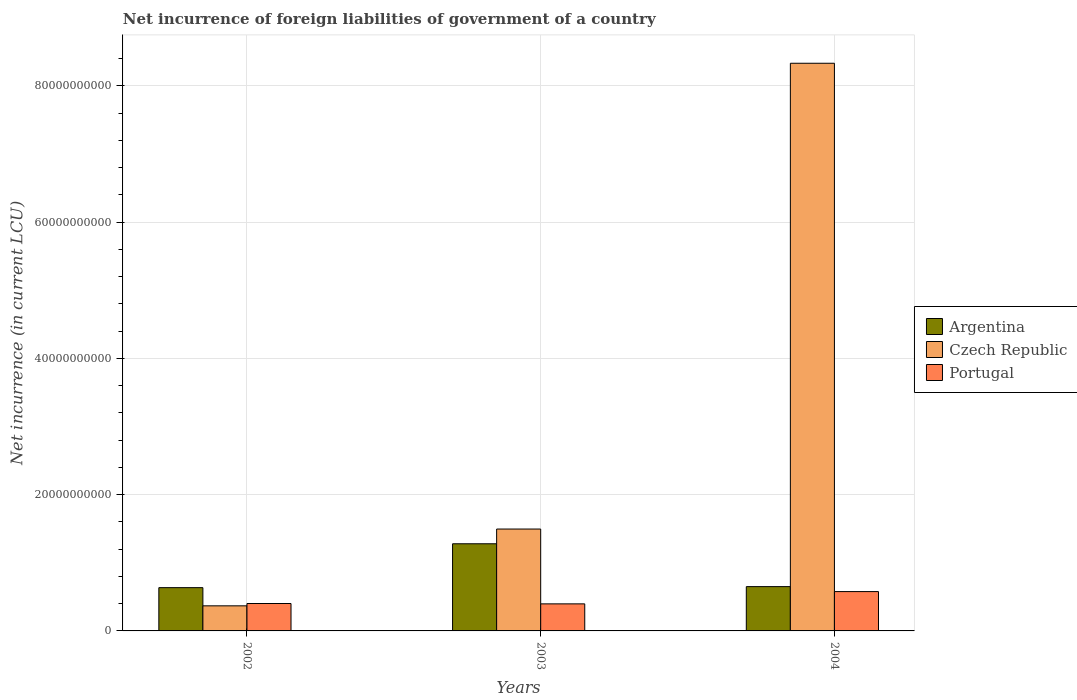Are the number of bars on each tick of the X-axis equal?
Provide a succinct answer. Yes. How many bars are there on the 1st tick from the left?
Provide a short and direct response. 3. How many bars are there on the 3rd tick from the right?
Offer a very short reply. 3. In how many cases, is the number of bars for a given year not equal to the number of legend labels?
Your answer should be very brief. 0. What is the net incurrence of foreign liabilities in Czech Republic in 2002?
Offer a very short reply. 3.68e+09. Across all years, what is the maximum net incurrence of foreign liabilities in Portugal?
Your answer should be compact. 5.77e+09. Across all years, what is the minimum net incurrence of foreign liabilities in Argentina?
Provide a succinct answer. 6.35e+09. What is the total net incurrence of foreign liabilities in Portugal in the graph?
Provide a short and direct response. 1.38e+1. What is the difference between the net incurrence of foreign liabilities in Portugal in 2003 and that in 2004?
Keep it short and to the point. -1.80e+09. What is the difference between the net incurrence of foreign liabilities in Portugal in 2003 and the net incurrence of foreign liabilities in Czech Republic in 2004?
Make the answer very short. -7.94e+1. What is the average net incurrence of foreign liabilities in Czech Republic per year?
Provide a short and direct response. 3.40e+1. In the year 2004, what is the difference between the net incurrence of foreign liabilities in Czech Republic and net incurrence of foreign liabilities in Portugal?
Your response must be concise. 7.76e+1. What is the ratio of the net incurrence of foreign liabilities in Argentina in 2003 to that in 2004?
Provide a succinct answer. 1.97. Is the net incurrence of foreign liabilities in Czech Republic in 2002 less than that in 2003?
Your answer should be very brief. Yes. Is the difference between the net incurrence of foreign liabilities in Czech Republic in 2003 and 2004 greater than the difference between the net incurrence of foreign liabilities in Portugal in 2003 and 2004?
Keep it short and to the point. No. What is the difference between the highest and the second highest net incurrence of foreign liabilities in Portugal?
Make the answer very short. 1.75e+09. What is the difference between the highest and the lowest net incurrence of foreign liabilities in Czech Republic?
Your response must be concise. 7.96e+1. Is the sum of the net incurrence of foreign liabilities in Portugal in 2002 and 2003 greater than the maximum net incurrence of foreign liabilities in Argentina across all years?
Give a very brief answer. No. Is it the case that in every year, the sum of the net incurrence of foreign liabilities in Argentina and net incurrence of foreign liabilities in Czech Republic is greater than the net incurrence of foreign liabilities in Portugal?
Offer a terse response. Yes. Are all the bars in the graph horizontal?
Provide a succinct answer. No. What is the difference between two consecutive major ticks on the Y-axis?
Make the answer very short. 2.00e+1. Does the graph contain any zero values?
Your response must be concise. No. Does the graph contain grids?
Offer a terse response. Yes. Where does the legend appear in the graph?
Ensure brevity in your answer.  Center right. What is the title of the graph?
Give a very brief answer. Net incurrence of foreign liabilities of government of a country. Does "Dominica" appear as one of the legend labels in the graph?
Make the answer very short. No. What is the label or title of the X-axis?
Provide a short and direct response. Years. What is the label or title of the Y-axis?
Give a very brief answer. Net incurrence (in current LCU). What is the Net incurrence (in current LCU) in Argentina in 2002?
Your answer should be very brief. 6.35e+09. What is the Net incurrence (in current LCU) of Czech Republic in 2002?
Make the answer very short. 3.68e+09. What is the Net incurrence (in current LCU) in Portugal in 2002?
Provide a short and direct response. 4.02e+09. What is the Net incurrence (in current LCU) of Argentina in 2003?
Ensure brevity in your answer.  1.28e+1. What is the Net incurrence (in current LCU) of Czech Republic in 2003?
Provide a succinct answer. 1.50e+1. What is the Net incurrence (in current LCU) in Portugal in 2003?
Your answer should be compact. 3.97e+09. What is the Net incurrence (in current LCU) in Argentina in 2004?
Offer a very short reply. 6.50e+09. What is the Net incurrence (in current LCU) of Czech Republic in 2004?
Ensure brevity in your answer.  8.33e+1. What is the Net incurrence (in current LCU) of Portugal in 2004?
Offer a terse response. 5.77e+09. Across all years, what is the maximum Net incurrence (in current LCU) of Argentina?
Your answer should be compact. 1.28e+1. Across all years, what is the maximum Net incurrence (in current LCU) of Czech Republic?
Make the answer very short. 8.33e+1. Across all years, what is the maximum Net incurrence (in current LCU) in Portugal?
Provide a succinct answer. 5.77e+09. Across all years, what is the minimum Net incurrence (in current LCU) of Argentina?
Make the answer very short. 6.35e+09. Across all years, what is the minimum Net incurrence (in current LCU) in Czech Republic?
Your answer should be compact. 3.68e+09. Across all years, what is the minimum Net incurrence (in current LCU) in Portugal?
Offer a terse response. 3.97e+09. What is the total Net incurrence (in current LCU) in Argentina in the graph?
Offer a very short reply. 2.56e+1. What is the total Net incurrence (in current LCU) of Czech Republic in the graph?
Your answer should be very brief. 1.02e+11. What is the total Net incurrence (in current LCU) in Portugal in the graph?
Make the answer very short. 1.38e+1. What is the difference between the Net incurrence (in current LCU) of Argentina in 2002 and that in 2003?
Your response must be concise. -6.44e+09. What is the difference between the Net incurrence (in current LCU) in Czech Republic in 2002 and that in 2003?
Offer a terse response. -1.13e+1. What is the difference between the Net incurrence (in current LCU) in Portugal in 2002 and that in 2003?
Provide a short and direct response. 5.12e+07. What is the difference between the Net incurrence (in current LCU) in Argentina in 2002 and that in 2004?
Keep it short and to the point. -1.53e+08. What is the difference between the Net incurrence (in current LCU) in Czech Republic in 2002 and that in 2004?
Make the answer very short. -7.96e+1. What is the difference between the Net incurrence (in current LCU) of Portugal in 2002 and that in 2004?
Ensure brevity in your answer.  -1.75e+09. What is the difference between the Net incurrence (in current LCU) of Argentina in 2003 and that in 2004?
Offer a terse response. 6.29e+09. What is the difference between the Net incurrence (in current LCU) of Czech Republic in 2003 and that in 2004?
Keep it short and to the point. -6.84e+1. What is the difference between the Net incurrence (in current LCU) in Portugal in 2003 and that in 2004?
Offer a very short reply. -1.80e+09. What is the difference between the Net incurrence (in current LCU) in Argentina in 2002 and the Net incurrence (in current LCU) in Czech Republic in 2003?
Keep it short and to the point. -8.60e+09. What is the difference between the Net incurrence (in current LCU) in Argentina in 2002 and the Net incurrence (in current LCU) in Portugal in 2003?
Your response must be concise. 2.38e+09. What is the difference between the Net incurrence (in current LCU) in Czech Republic in 2002 and the Net incurrence (in current LCU) in Portugal in 2003?
Your response must be concise. -2.90e+08. What is the difference between the Net incurrence (in current LCU) in Argentina in 2002 and the Net incurrence (in current LCU) in Czech Republic in 2004?
Offer a terse response. -7.70e+1. What is the difference between the Net incurrence (in current LCU) of Argentina in 2002 and the Net incurrence (in current LCU) of Portugal in 2004?
Offer a terse response. 5.77e+08. What is the difference between the Net incurrence (in current LCU) of Czech Republic in 2002 and the Net incurrence (in current LCU) of Portugal in 2004?
Your answer should be very brief. -2.09e+09. What is the difference between the Net incurrence (in current LCU) in Argentina in 2003 and the Net incurrence (in current LCU) in Czech Republic in 2004?
Ensure brevity in your answer.  -7.05e+1. What is the difference between the Net incurrence (in current LCU) in Argentina in 2003 and the Net incurrence (in current LCU) in Portugal in 2004?
Your answer should be very brief. 7.02e+09. What is the difference between the Net incurrence (in current LCU) in Czech Republic in 2003 and the Net incurrence (in current LCU) in Portugal in 2004?
Your answer should be compact. 9.18e+09. What is the average Net incurrence (in current LCU) of Argentina per year?
Your response must be concise. 8.55e+09. What is the average Net incurrence (in current LCU) of Czech Republic per year?
Your response must be concise. 3.40e+1. What is the average Net incurrence (in current LCU) in Portugal per year?
Offer a very short reply. 4.59e+09. In the year 2002, what is the difference between the Net incurrence (in current LCU) in Argentina and Net incurrence (in current LCU) in Czech Republic?
Your response must be concise. 2.67e+09. In the year 2002, what is the difference between the Net incurrence (in current LCU) in Argentina and Net incurrence (in current LCU) in Portugal?
Give a very brief answer. 2.33e+09. In the year 2002, what is the difference between the Net incurrence (in current LCU) in Czech Republic and Net incurrence (in current LCU) in Portugal?
Keep it short and to the point. -3.41e+08. In the year 2003, what is the difference between the Net incurrence (in current LCU) of Argentina and Net incurrence (in current LCU) of Czech Republic?
Your answer should be compact. -2.16e+09. In the year 2003, what is the difference between the Net incurrence (in current LCU) of Argentina and Net incurrence (in current LCU) of Portugal?
Provide a short and direct response. 8.82e+09. In the year 2003, what is the difference between the Net incurrence (in current LCU) of Czech Republic and Net incurrence (in current LCU) of Portugal?
Your response must be concise. 1.10e+1. In the year 2004, what is the difference between the Net incurrence (in current LCU) in Argentina and Net incurrence (in current LCU) in Czech Republic?
Give a very brief answer. -7.68e+1. In the year 2004, what is the difference between the Net incurrence (in current LCU) in Argentina and Net incurrence (in current LCU) in Portugal?
Offer a terse response. 7.30e+08. In the year 2004, what is the difference between the Net incurrence (in current LCU) in Czech Republic and Net incurrence (in current LCU) in Portugal?
Give a very brief answer. 7.76e+1. What is the ratio of the Net incurrence (in current LCU) of Argentina in 2002 to that in 2003?
Your response must be concise. 0.5. What is the ratio of the Net incurrence (in current LCU) of Czech Republic in 2002 to that in 2003?
Keep it short and to the point. 0.25. What is the ratio of the Net incurrence (in current LCU) in Portugal in 2002 to that in 2003?
Ensure brevity in your answer.  1.01. What is the ratio of the Net incurrence (in current LCU) of Argentina in 2002 to that in 2004?
Give a very brief answer. 0.98. What is the ratio of the Net incurrence (in current LCU) in Czech Republic in 2002 to that in 2004?
Make the answer very short. 0.04. What is the ratio of the Net incurrence (in current LCU) of Portugal in 2002 to that in 2004?
Offer a very short reply. 0.7. What is the ratio of the Net incurrence (in current LCU) of Argentina in 2003 to that in 2004?
Your response must be concise. 1.97. What is the ratio of the Net incurrence (in current LCU) of Czech Republic in 2003 to that in 2004?
Make the answer very short. 0.18. What is the ratio of the Net incurrence (in current LCU) in Portugal in 2003 to that in 2004?
Give a very brief answer. 0.69. What is the difference between the highest and the second highest Net incurrence (in current LCU) of Argentina?
Your response must be concise. 6.29e+09. What is the difference between the highest and the second highest Net incurrence (in current LCU) of Czech Republic?
Keep it short and to the point. 6.84e+1. What is the difference between the highest and the second highest Net incurrence (in current LCU) of Portugal?
Offer a terse response. 1.75e+09. What is the difference between the highest and the lowest Net incurrence (in current LCU) of Argentina?
Provide a succinct answer. 6.44e+09. What is the difference between the highest and the lowest Net incurrence (in current LCU) in Czech Republic?
Your response must be concise. 7.96e+1. What is the difference between the highest and the lowest Net incurrence (in current LCU) of Portugal?
Your answer should be compact. 1.80e+09. 